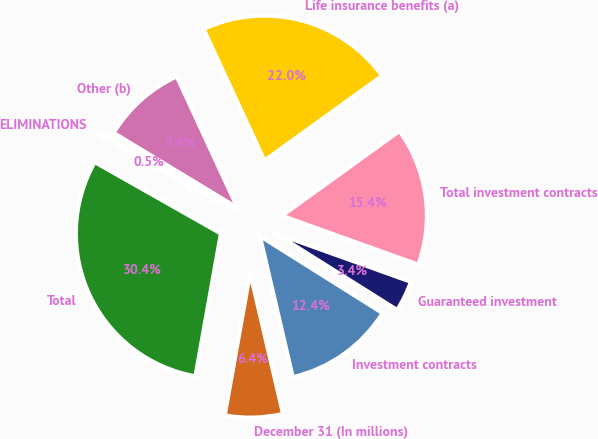Convert chart to OTSL. <chart><loc_0><loc_0><loc_500><loc_500><pie_chart><fcel>December 31 (In millions)<fcel>Investment contracts<fcel>Guaranteed investment<fcel>Total investment contracts<fcel>Life insurance benefits (a)<fcel>Other (b)<fcel>ELIMINATIONS<fcel>Total<nl><fcel>6.45%<fcel>12.43%<fcel>3.45%<fcel>15.42%<fcel>21.96%<fcel>9.44%<fcel>0.46%<fcel>30.39%<nl></chart> 